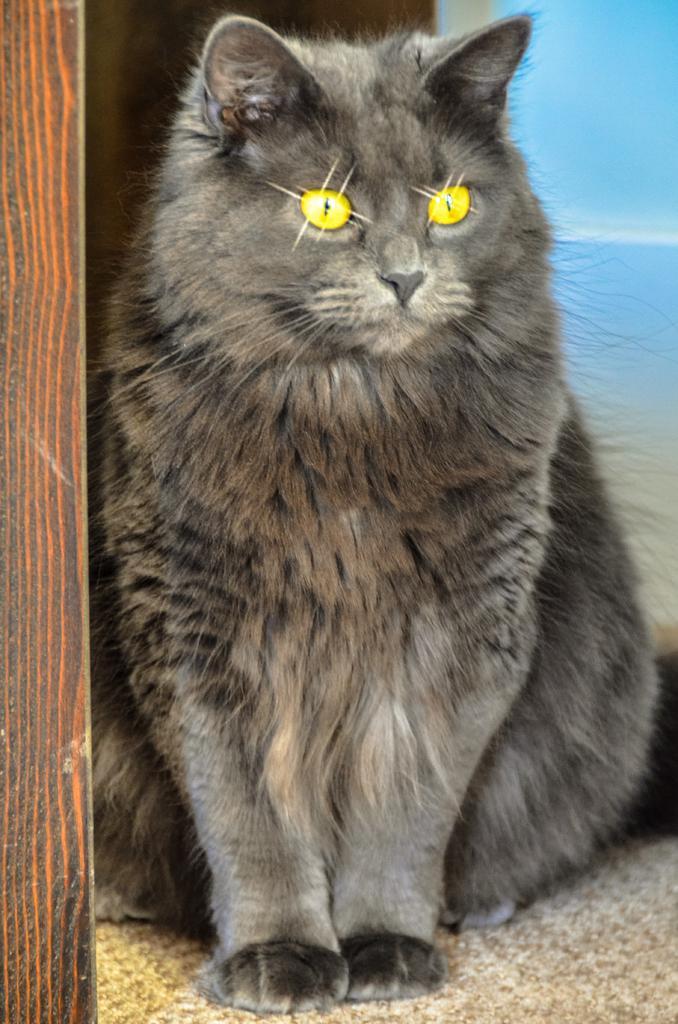Please provide a concise description of this image. In the image we can see a cat, with yellow eyes. This is a carpet, wooden pole and the background is pale blue in color. 